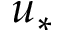Convert formula to latex. <formula><loc_0><loc_0><loc_500><loc_500>u _ { * }</formula> 